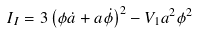<formula> <loc_0><loc_0><loc_500><loc_500>I _ { I } = 3 \left ( \phi \dot { a } + a \dot { \phi } \right ) ^ { 2 } - V _ { 1 } a ^ { 2 } \phi ^ { 2 }</formula> 